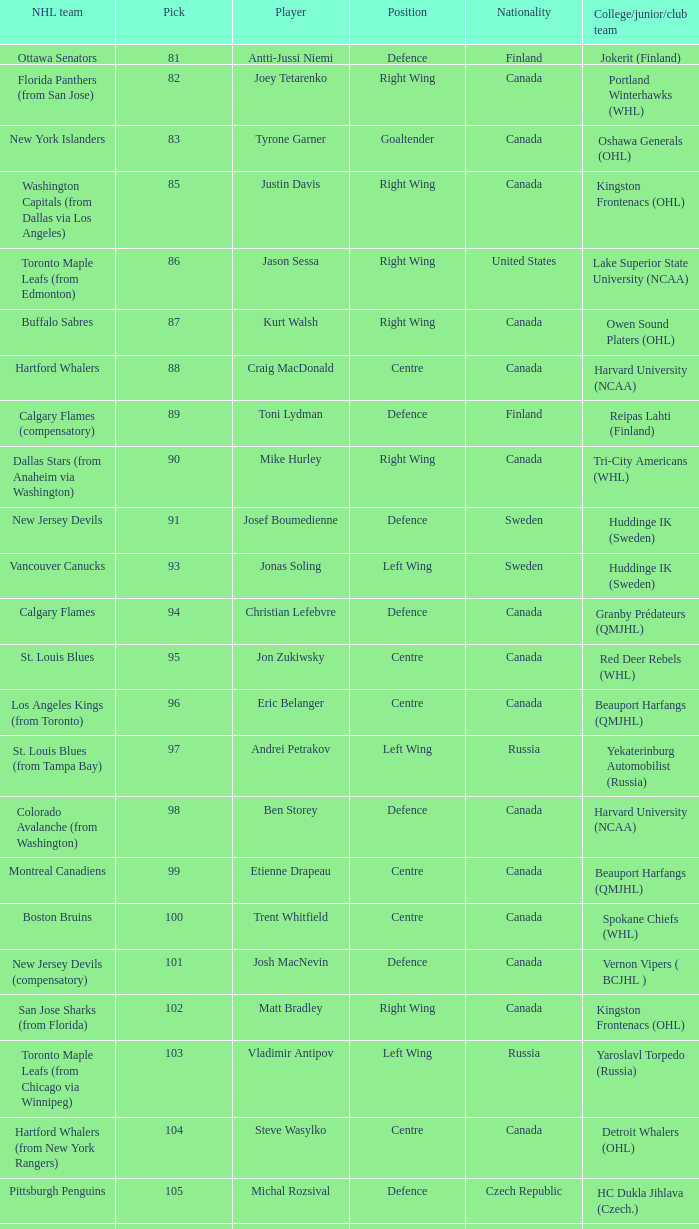Give me the full table as a dictionary. {'header': ['NHL team', 'Pick', 'Player', 'Position', 'Nationality', 'College/junior/club team'], 'rows': [['Ottawa Senators', '81', 'Antti-Jussi Niemi', 'Defence', 'Finland', 'Jokerit (Finland)'], ['Florida Panthers (from San Jose)', '82', 'Joey Tetarenko', 'Right Wing', 'Canada', 'Portland Winterhawks (WHL)'], ['New York Islanders', '83', 'Tyrone Garner', 'Goaltender', 'Canada', 'Oshawa Generals (OHL)'], ['Washington Capitals (from Dallas via Los Angeles)', '85', 'Justin Davis', 'Right Wing', 'Canada', 'Kingston Frontenacs (OHL)'], ['Toronto Maple Leafs (from Edmonton)', '86', 'Jason Sessa', 'Right Wing', 'United States', 'Lake Superior State University (NCAA)'], ['Buffalo Sabres', '87', 'Kurt Walsh', 'Right Wing', 'Canada', 'Owen Sound Platers (OHL)'], ['Hartford Whalers', '88', 'Craig MacDonald', 'Centre', 'Canada', 'Harvard University (NCAA)'], ['Calgary Flames (compensatory)', '89', 'Toni Lydman', 'Defence', 'Finland', 'Reipas Lahti (Finland)'], ['Dallas Stars (from Anaheim via Washington)', '90', 'Mike Hurley', 'Right Wing', 'Canada', 'Tri-City Americans (WHL)'], ['New Jersey Devils', '91', 'Josef Boumedienne', 'Defence', 'Sweden', 'Huddinge IK (Sweden)'], ['Vancouver Canucks', '93', 'Jonas Soling', 'Left Wing', 'Sweden', 'Huddinge IK (Sweden)'], ['Calgary Flames', '94', 'Christian Lefebvre', 'Defence', 'Canada', 'Granby Prédateurs (QMJHL)'], ['St. Louis Blues', '95', 'Jon Zukiwsky', 'Centre', 'Canada', 'Red Deer Rebels (WHL)'], ['Los Angeles Kings (from Toronto)', '96', 'Eric Belanger', 'Centre', 'Canada', 'Beauport Harfangs (QMJHL)'], ['St. Louis Blues (from Tampa Bay)', '97', 'Andrei Petrakov', 'Left Wing', 'Russia', 'Yekaterinburg Automobilist (Russia)'], ['Colorado Avalanche (from Washington)', '98', 'Ben Storey', 'Defence', 'Canada', 'Harvard University (NCAA)'], ['Montreal Canadiens', '99', 'Etienne Drapeau', 'Centre', 'Canada', 'Beauport Harfangs (QMJHL)'], ['Boston Bruins', '100', 'Trent Whitfield', 'Centre', 'Canada', 'Spokane Chiefs (WHL)'], ['New Jersey Devils (compensatory)', '101', 'Josh MacNevin', 'Defence', 'Canada', 'Vernon Vipers ( BCJHL )'], ['San Jose Sharks (from Florida)', '102', 'Matt Bradley', 'Right Wing', 'Canada', 'Kingston Frontenacs (OHL)'], ['Toronto Maple Leafs (from Chicago via Winnipeg)', '103', 'Vladimir Antipov', 'Left Wing', 'Russia', 'Yaroslavl Torpedo (Russia)'], ['Hartford Whalers (from New York Rangers)', '104', 'Steve Wasylko', 'Centre', 'Canada', 'Detroit Whalers (OHL)'], ['Pittsburgh Penguins', '105', 'Michal Rozsival', 'Defence', 'Czech Republic', 'HC Dukla Jihlava (Czech.)'], ['Buffalo Sabres (from Philadelphia via San Jose)', '106', 'Mike Martone', 'Defence', 'Canada', 'Peterborough Petes (OHL)'], ['Colorado Avalanche', '107', 'Randy Petruk', 'Goaltender', 'Canada', 'Kamloops Blazers (WHL)']]} What position does that draft pick play from Lake Superior State University (NCAA)? Right Wing. 